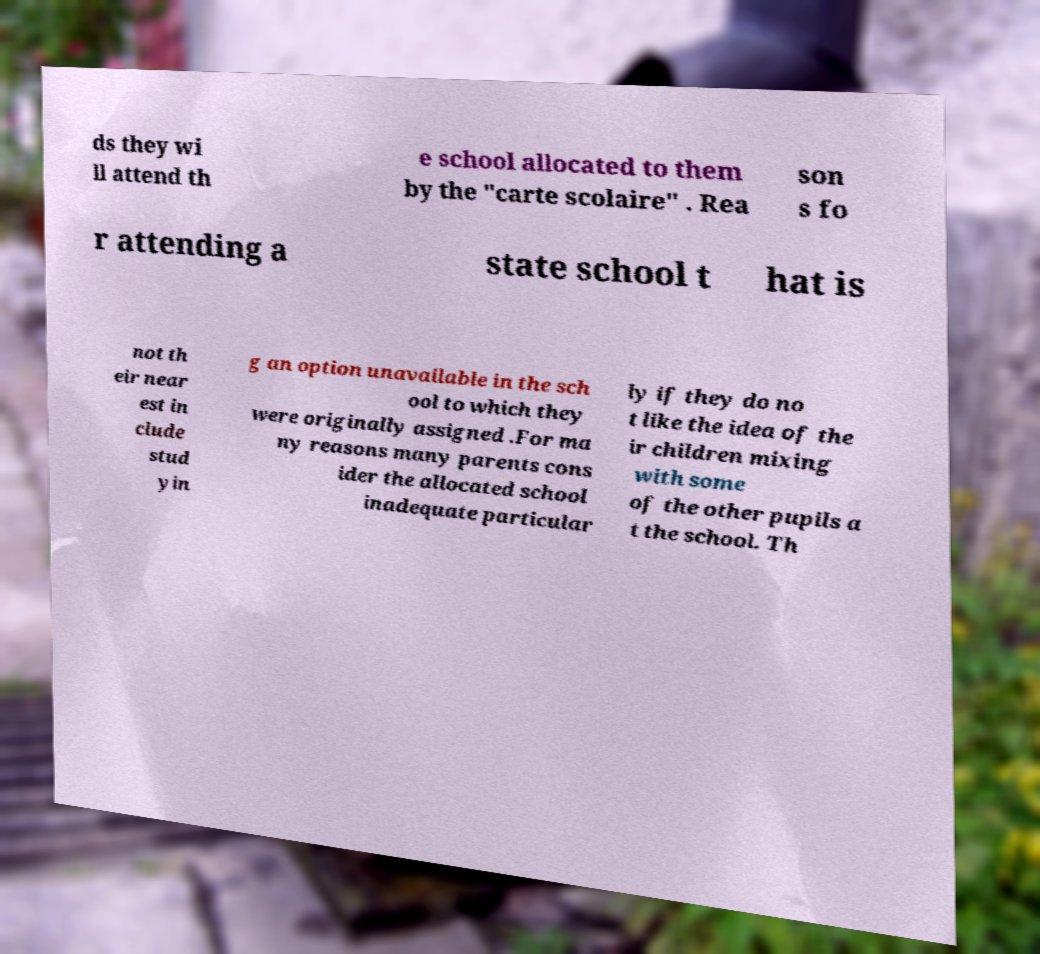Could you extract and type out the text from this image? ds they wi ll attend th e school allocated to them by the "carte scolaire" . Rea son s fo r attending a state school t hat is not th eir near est in clude stud yin g an option unavailable in the sch ool to which they were originally assigned .For ma ny reasons many parents cons ider the allocated school inadequate particular ly if they do no t like the idea of the ir children mixing with some of the other pupils a t the school. Th 